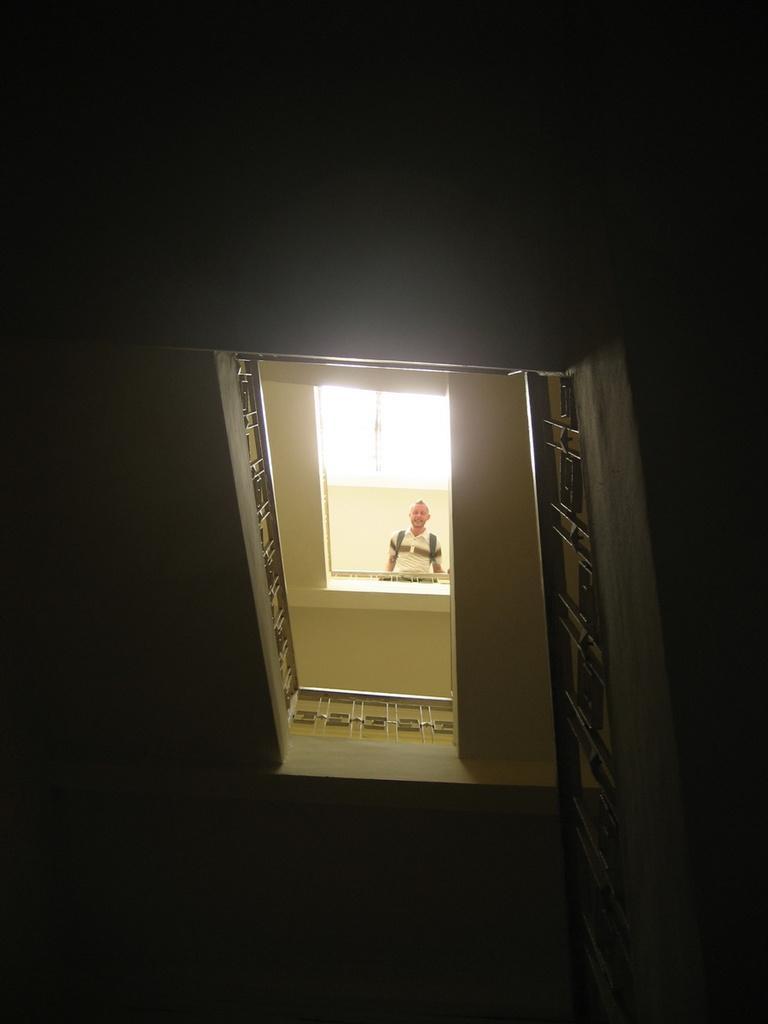Describe this image in one or two sentences. In this picture, we can see a person, railing and the dark background. 